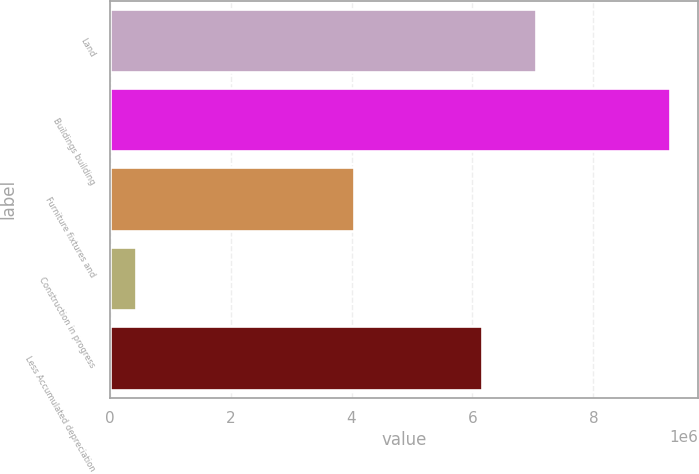<chart> <loc_0><loc_0><loc_500><loc_500><bar_chart><fcel>Land<fcel>Buildings building<fcel>Furniture fixtures and<fcel>Construction in progress<fcel>Less Accumulated depreciation<nl><fcel>7.04776e+06<fcel>9.26446e+06<fcel>4.04089e+06<fcel>437434<fcel>6.16505e+06<nl></chart> 